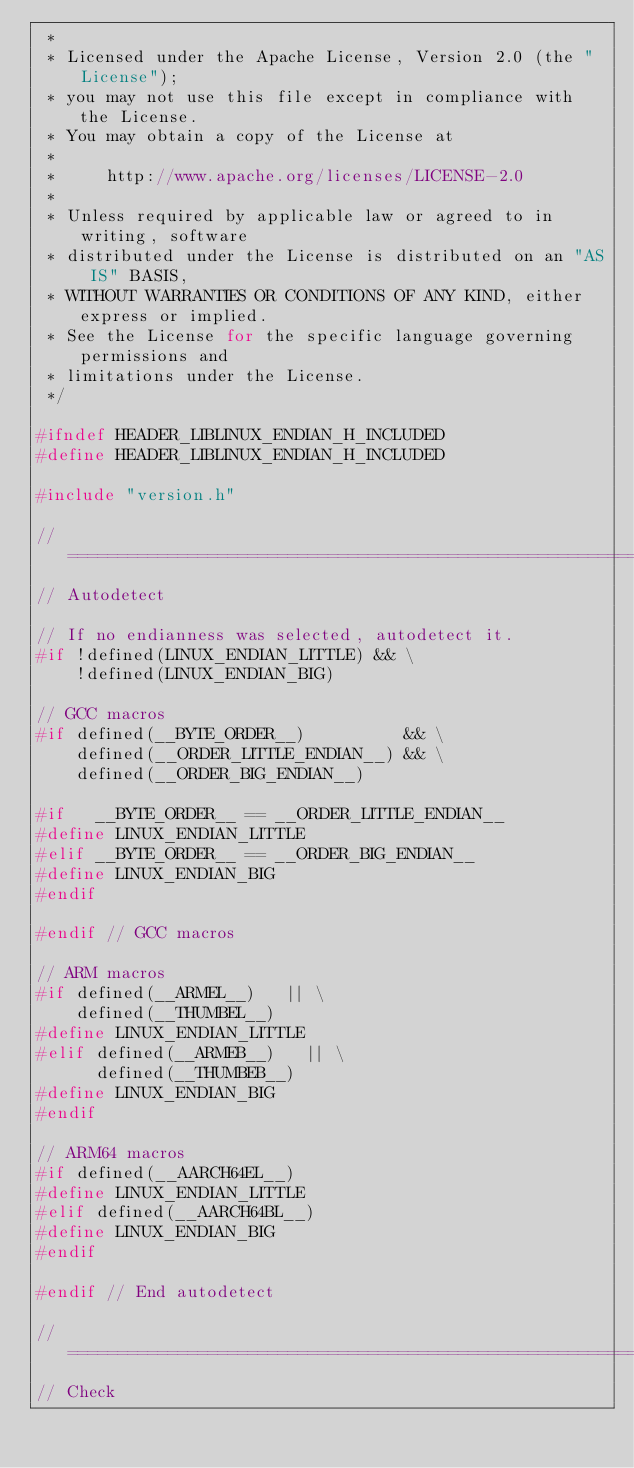<code> <loc_0><loc_0><loc_500><loc_500><_C_> *
 * Licensed under the Apache License, Version 2.0 (the "License");
 * you may not use this file except in compliance with the License.
 * You may obtain a copy of the License at
 *
 *     http://www.apache.org/licenses/LICENSE-2.0
 *
 * Unless required by applicable law or agreed to in writing, software
 * distributed under the License is distributed on an "AS IS" BASIS,
 * WITHOUT WARRANTIES OR CONDITIONS OF ANY KIND, either express or implied.
 * See the License for the specific language governing permissions and
 * limitations under the License.
 */

#ifndef HEADER_LIBLINUX_ENDIAN_H_INCLUDED
#define HEADER_LIBLINUX_ENDIAN_H_INCLUDED

#include "version.h"

//==============================================================================
// Autodetect

// If no endianness was selected, autodetect it.
#if !defined(LINUX_ENDIAN_LITTLE) && \
    !defined(LINUX_ENDIAN_BIG)

// GCC macros
#if defined(__BYTE_ORDER__)          && \
    defined(__ORDER_LITTLE_ENDIAN__) && \
    defined(__ORDER_BIG_ENDIAN__)

#if   __BYTE_ORDER__ == __ORDER_LITTLE_ENDIAN__
#define LINUX_ENDIAN_LITTLE
#elif __BYTE_ORDER__ == __ORDER_BIG_ENDIAN__
#define LINUX_ENDIAN_BIG
#endif

#endif // GCC macros

// ARM macros
#if defined(__ARMEL__)   || \
    defined(__THUMBEL__)
#define LINUX_ENDIAN_LITTLE
#elif defined(__ARMEB__)   || \
      defined(__THUMBEB__)
#define LINUX_ENDIAN_BIG
#endif

// ARM64 macros
#if defined(__AARCH64EL__)
#define LINUX_ENDIAN_LITTLE
#elif defined(__AARCH64BL__)
#define LINUX_ENDIAN_BIG
#endif

#endif // End autodetect

//==============================================================================
// Check
</code> 